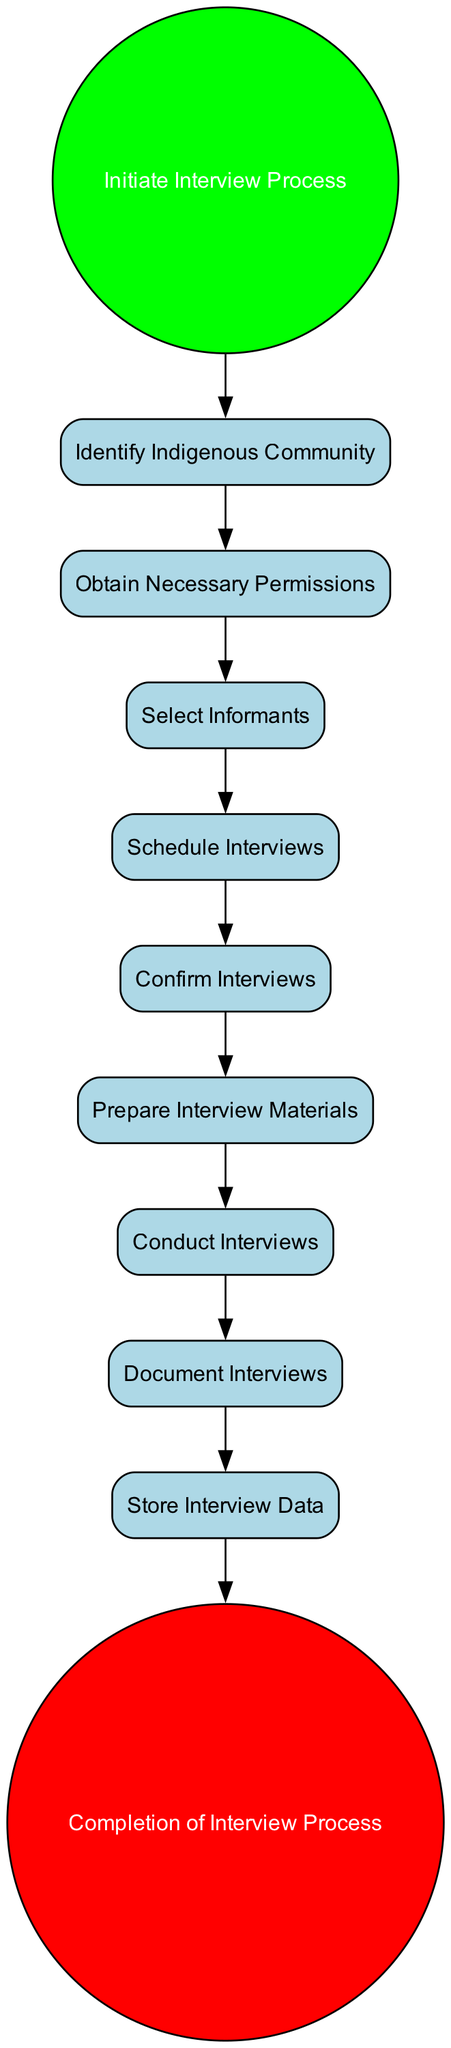What is the first step in the interview process? The first step in the process, indicated by a starting event in the diagram, is 'Initiate Interview Process'.
Answer: Initiate Interview Process How many activities are present in the diagram? By reviewing the nodes classified as activities, we count a total of eight activities: 'Identify Indigenous Community', 'Obtain Necessary Permissions', 'Select Informants', 'Schedule Interviews', 'Confirm Interviews', 'Prepare Interview Materials', 'Conduct Interviews', and 'Document Interviews'.
Answer: Eight What comes after confirming interviews? Following 'Confirm Interviews', the next step indicated in the flow of the diagram is 'Prepare Interview Materials'.
Answer: Prepare Interview Materials Which activity is performed just before 'Conduct Interviews'? The activity performed just before 'Conduct Interviews' is 'Prepare Interview Materials', as indicated by the directed flow in the diagram.
Answer: Prepare Interview Materials How many end events does the diagram have? The diagram contains one end event, represented by 'Completion of Interview Process'. This is the final node in the flow, marking the end of the process.
Answer: One What is the last activity before completing the interview process? The last activity performed before 'Completion of Interview Process' is 'Store Interview Data', which feeds directly into the end event.
Answer: Store Interview Data Which step involves selecting individuals to interview? The step that involves selecting individuals to interview is 'Select Informants', which is specifically highlighted in the sequence of events in the diagram.
Answer: Select Informants What is the relationship between 'Schedule Interviews' and 'Confirm Interviews'? The relationship is that 'Schedule Interviews' directly leads to 'Confirm Interviews', as indicated by the flow arrow connecting the two activities in the diagram.
Answer: Directly leads to What is the step before 'Document Interviews'? The step that comes right before 'Document Interviews' is 'Conduct Interviews', which must occur first according to the flow progression shown in the diagram.
Answer: Conduct Interviews 